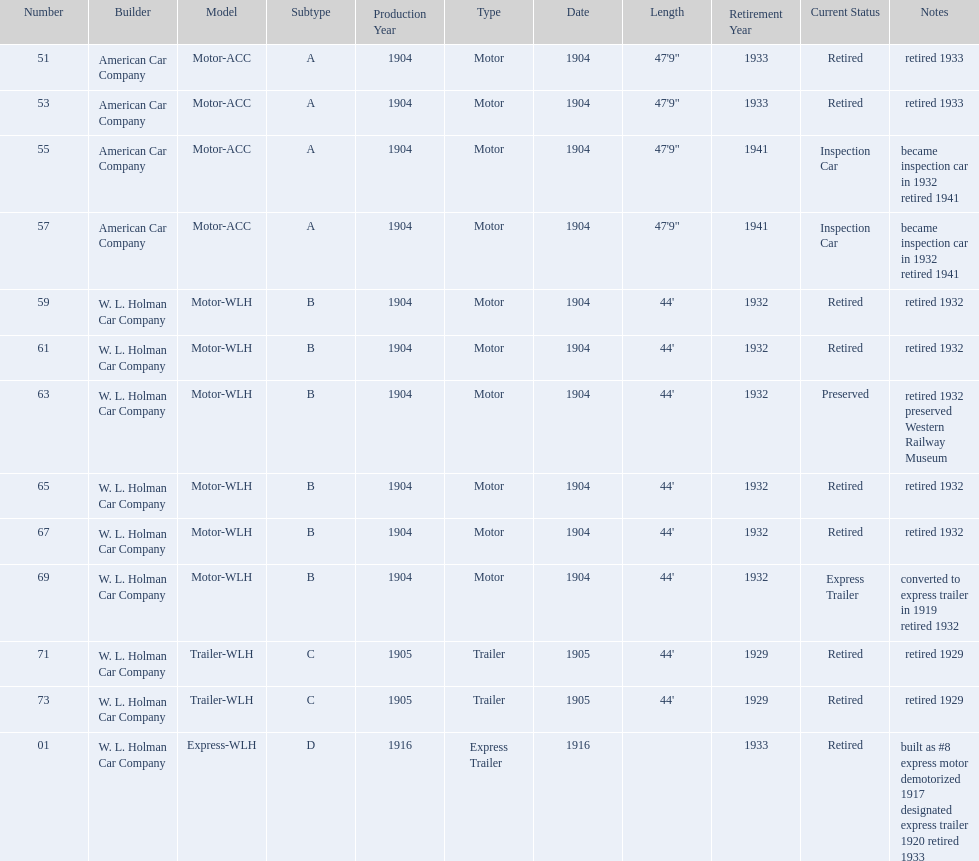In 1906, how many total rolling stock vehicles were in service? 12. 